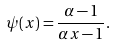Convert formula to latex. <formula><loc_0><loc_0><loc_500><loc_500>\psi ( x ) = \frac { \alpha - 1 } { \alpha x - 1 } .</formula> 